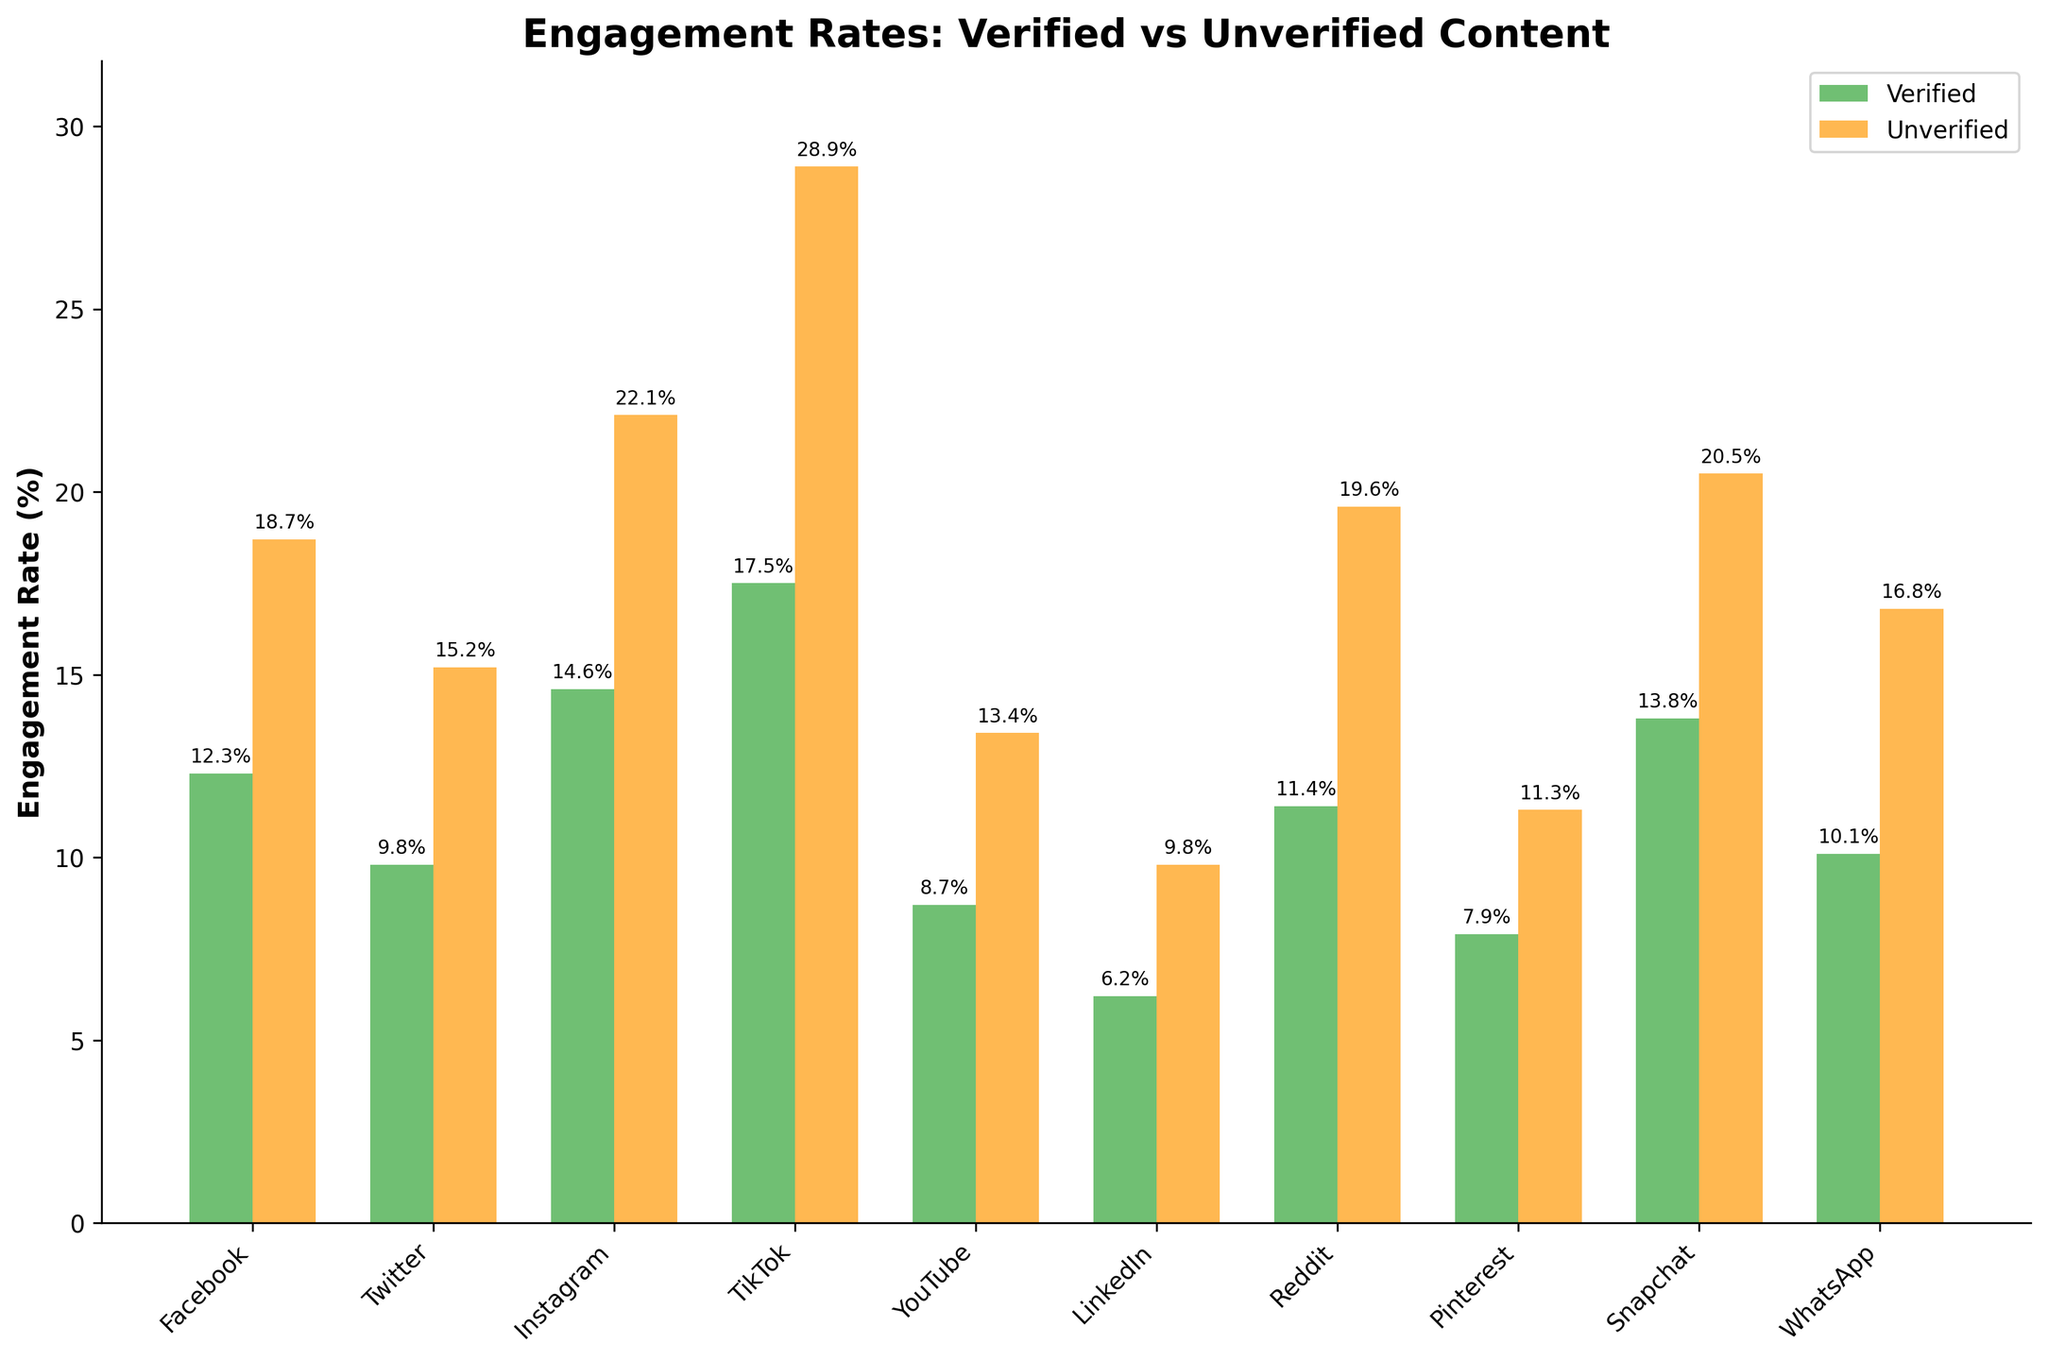Which platform has the highest engagement rate for unverified content? The highest bar in the unverified content section indicates TikTok has the highest engagement rate, which is 28.9%.
Answer: TikTok What is the difference in engagement rates for verified and unverified content on Facebook? The engagement rate for verified content on Facebook is 12.3%, and for unverified content, it is 18.7%. The difference is 18.7% - 12.3% = 6.4%.
Answer: 6.4% Which platform shows the smallest difference in engagement rates between verified and unverified content? Comparing the differences for each platform: Facebook (6.4%), Twitter (5.4%), Instagram (7.5%), TikTok (11.4%), YouTube (4.7%), LinkedIn (3.6%), Reddit (8.2%), Pinterest (3.4%), Snapchat (6.7%), WhatsApp (6.7%). The smallest difference is for Pinterest, which is 3.4%.
Answer: Pinterest How many platforms have a verified content engagement rate of more than 10%? Count the bars greater than 10% in the verified content section: Facebook (12.3%), Instagram (14.6%), TikTok (17.5%), Reddit (11.4%), Snapchat (13.8%), WhatsApp (10.1%). There are 6 platforms.
Answer: 6 What is the average engagement rate for verified content across all platforms? Sum the verified content engagement rates: 12.3 + 9.8 + 14.6 + 17.5 + 8.7 + 6.2 + 11.4 + 7.9 + 13.8 + 10.1 = 112.3. Divide by the number of platforms (10): 112.3 / 10 = 11.23%.
Answer: 11.23% Which platform shows the largest difference between verified and unverified content engagement rates? Comparing the differences for each platform as before: Facebook (6.4%), Twitter (5.4%), Instagram (7.5%), TikTok (11.4%), YouTube (4.7%), LinkedIn (3.6%), Reddit (8.2%), Pinterest (3.4%), Snapchat (6.7%), WhatsApp (6.7%). The largest difference is for TikTok, which is 11.4%.
Answer: TikTok Are there any platforms where the engagement rate for unverified content is less than 10%? Review the unverified content engagement rates, and all are above 10%. None of the platforms have an engagement rate for unverified content less than 10%.
Answer: No Which platform has the lowest engagement rate for verified content? The lowest bar in the verified content section indicates LinkedIn has the lowest engagement rate, which is 6.2%.
Answer: LinkedIn What is the combined engagement rate for verified content on Instagram and TikTok? Add Instagram's verified engagement rate (14.6%) and TikTok's verified engagement rate (17.5%). 14.6% + 17.5% = 32.1%.
Answer: 32.1% Is the engagement rate for verified content on Twitter higher or lower than on YouTube? The engagement rate for verified content on Twitter is 9.8%, while on YouTube it is 8.7%. Therefore, it is higher on Twitter.
Answer: Higher 